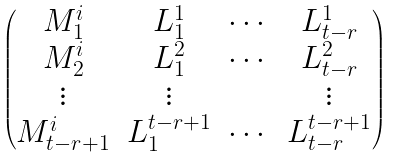<formula> <loc_0><loc_0><loc_500><loc_500>\begin{pmatrix} M _ { 1 } ^ { i } & L _ { 1 } ^ { 1 } & \cdots & L _ { t - r } ^ { 1 } \\ M _ { 2 } ^ { i } & L _ { 1 } ^ { 2 } & \cdots & L _ { t - r } ^ { 2 } \\ \vdots & \vdots & & \vdots \\ M _ { t - r + 1 } ^ { i } & L _ { 1 } ^ { t - r + 1 } & \cdots & L _ { t - r } ^ { t - r + 1 } \end{pmatrix}</formula> 